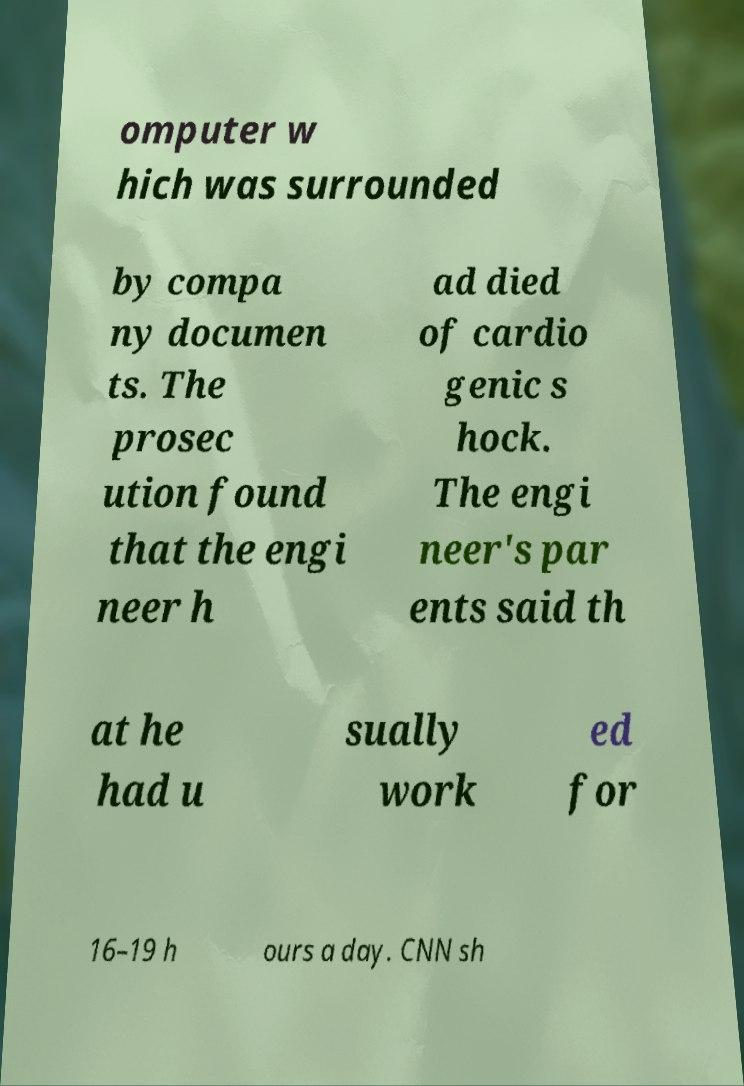There's text embedded in this image that I need extracted. Can you transcribe it verbatim? omputer w hich was surrounded by compa ny documen ts. The prosec ution found that the engi neer h ad died of cardio genic s hock. The engi neer's par ents said th at he had u sually work ed for 16–19 h ours a day. CNN sh 